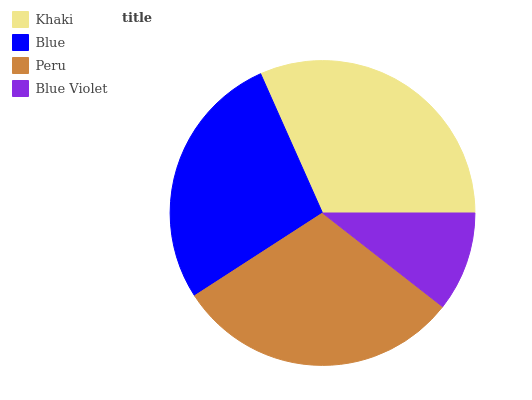Is Blue Violet the minimum?
Answer yes or no. Yes. Is Khaki the maximum?
Answer yes or no. Yes. Is Blue the minimum?
Answer yes or no. No. Is Blue the maximum?
Answer yes or no. No. Is Khaki greater than Blue?
Answer yes or no. Yes. Is Blue less than Khaki?
Answer yes or no. Yes. Is Blue greater than Khaki?
Answer yes or no. No. Is Khaki less than Blue?
Answer yes or no. No. Is Peru the high median?
Answer yes or no. Yes. Is Blue the low median?
Answer yes or no. Yes. Is Blue the high median?
Answer yes or no. No. Is Blue Violet the low median?
Answer yes or no. No. 